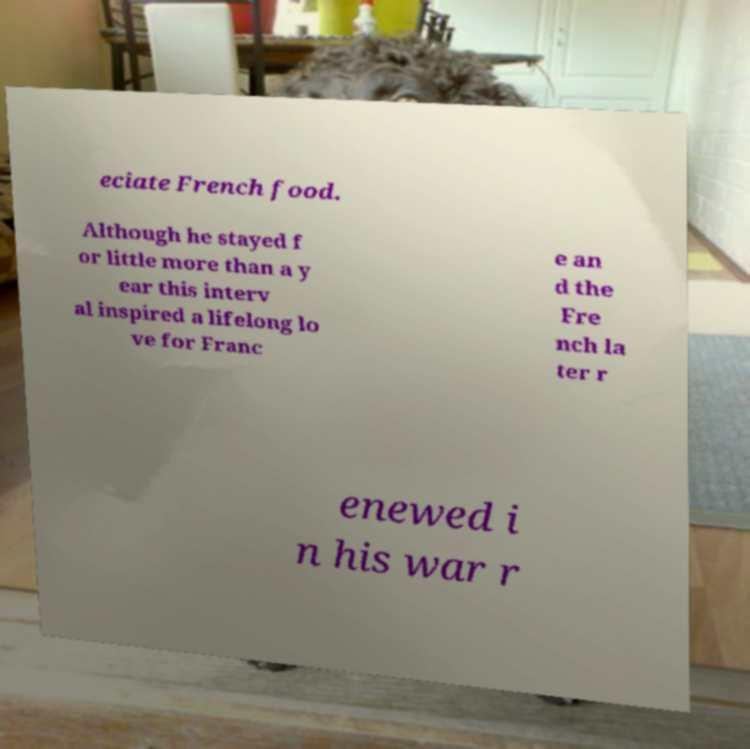Can you read and provide the text displayed in the image?This photo seems to have some interesting text. Can you extract and type it out for me? eciate French food. Although he stayed f or little more than a y ear this interv al inspired a lifelong lo ve for Franc e an d the Fre nch la ter r enewed i n his war r 